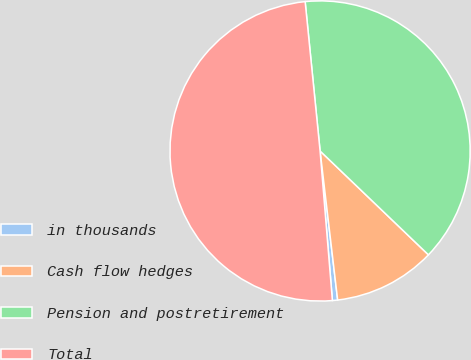Convert chart. <chart><loc_0><loc_0><loc_500><loc_500><pie_chart><fcel>in thousands<fcel>Cash flow hedges<fcel>Pension and postretirement<fcel>Total<nl><fcel>0.56%<fcel>10.97%<fcel>38.75%<fcel>49.72%<nl></chart> 